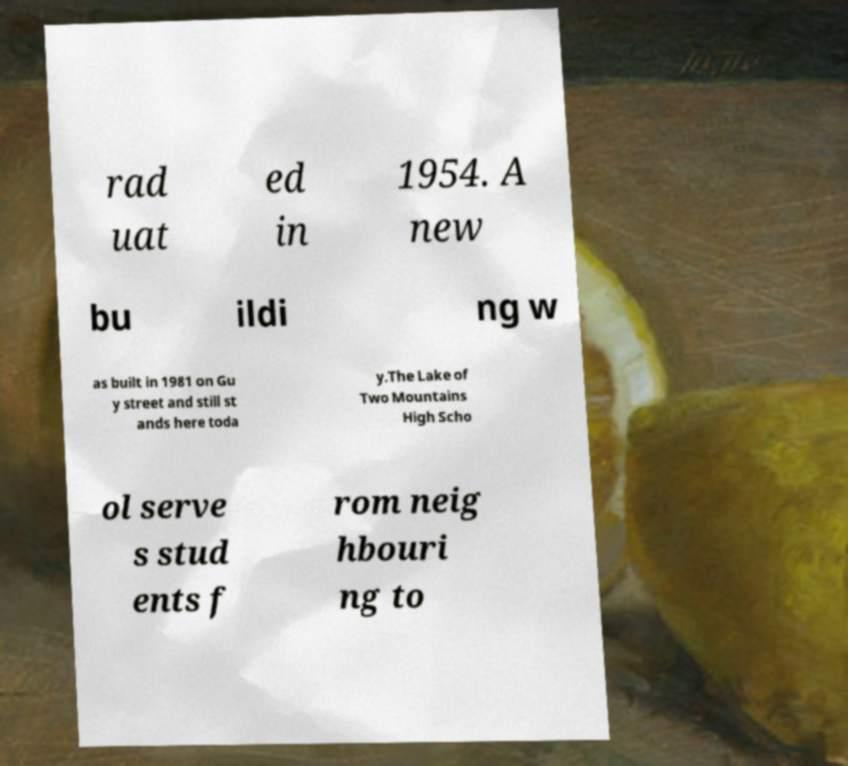I need the written content from this picture converted into text. Can you do that? rad uat ed in 1954. A new bu ildi ng w as built in 1981 on Gu y street and still st ands here toda y.The Lake of Two Mountains High Scho ol serve s stud ents f rom neig hbouri ng to 